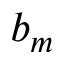<formula> <loc_0><loc_0><loc_500><loc_500>b _ { m }</formula> 